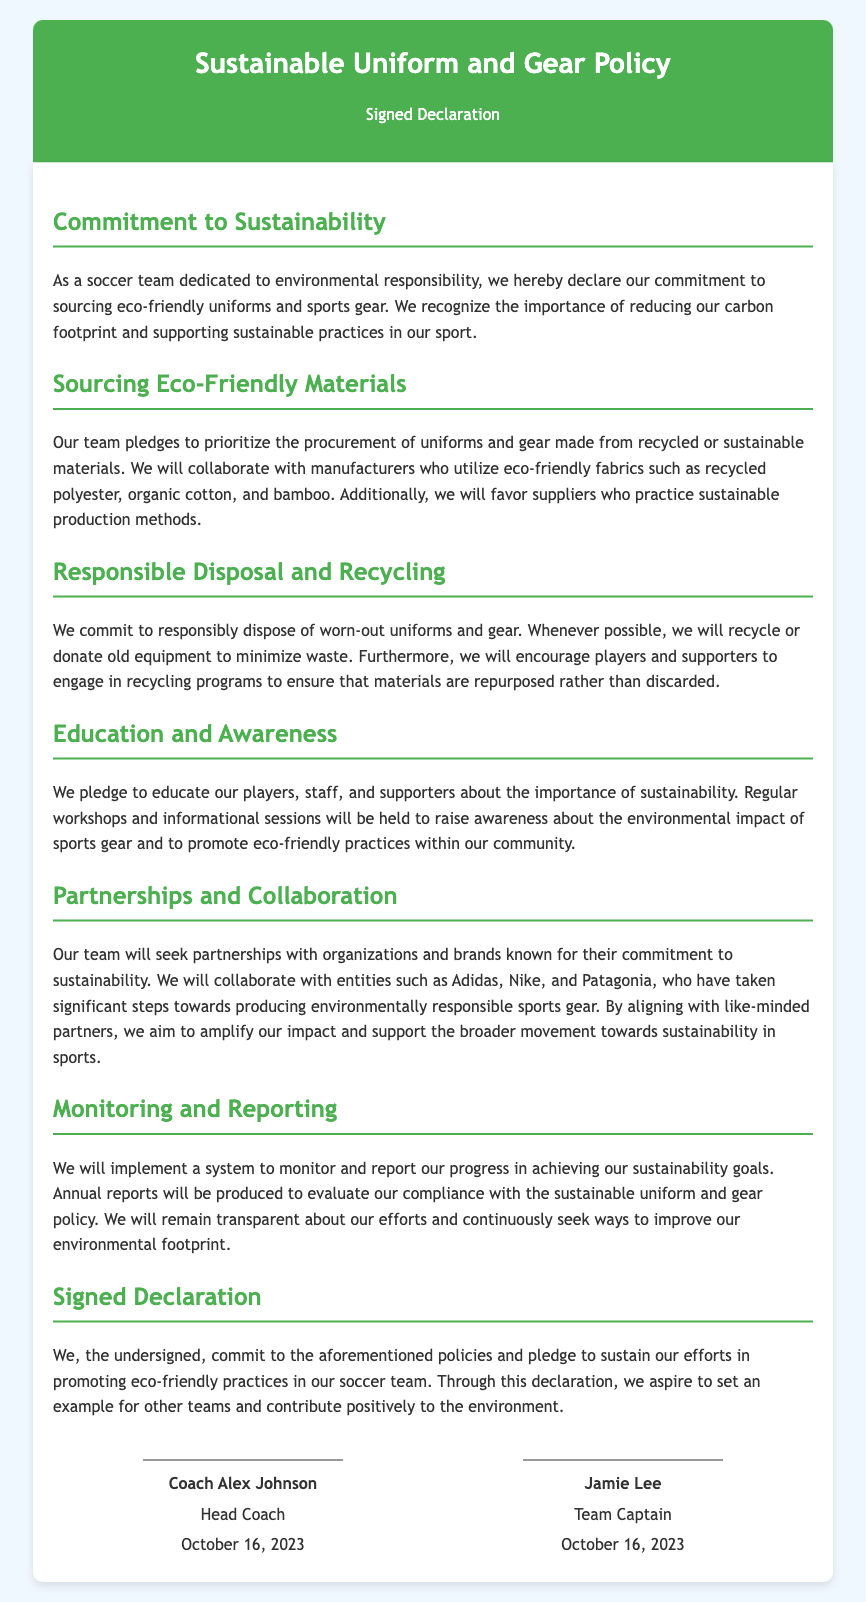What is the title of the document? The title of the document is clearly stated in the header as "Sustainable Uniform and Gear Policy."
Answer: Sustainable Uniform and Gear Policy Who is the Head Coach? The signed declaration lists Coach Alex Johnson as the Head Coach.
Answer: Coach Alex Johnson What date was the declaration signed? The document specifies the signing date as October 16, 2023, mentioned under both signatures.
Answer: October 16, 2023 What type of materials does the team prefer for uniforms? The document states that the team prioritizes the procurement of uniforms made from recycled or sustainable materials.
Answer: Recycled or sustainable materials Which brands does the team plan to collaborate with? The declaration mentions Adidas, Nike, and Patagonia as brands for potential collaboration.
Answer: Adidas, Nike, and Patagonia What is the primary commitment stated in the document? The document emphasizes the team's commitment to sourcing eco-friendly uniforms and sports gear.
Answer: Sourcing eco-friendly uniforms and sports gear How does the team plan to dispose of worn-out gear? The document expresses the commitment to responsibly dispose of worn-out uniforms and gear, indicating recycling or donating as preferred methods.
Answer: Recycling or donating What is one educational initiative mentioned in the declaration? The declaration mentions that regular workshops and informational sessions will be held to raise awareness about sustainability.
Answer: Workshops and informational sessions What will be produced to evaluate sustainability compliance? The document states that annual reports will be produced to evaluate compliance with the sustainable uniform and gear policy.
Answer: Annual reports 